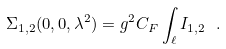Convert formula to latex. <formula><loc_0><loc_0><loc_500><loc_500>\Sigma _ { 1 , 2 } ( 0 , 0 , \lambda ^ { 2 } ) = g ^ { 2 } C _ { F } \int _ { \ell } I _ { 1 , 2 } \ .</formula> 